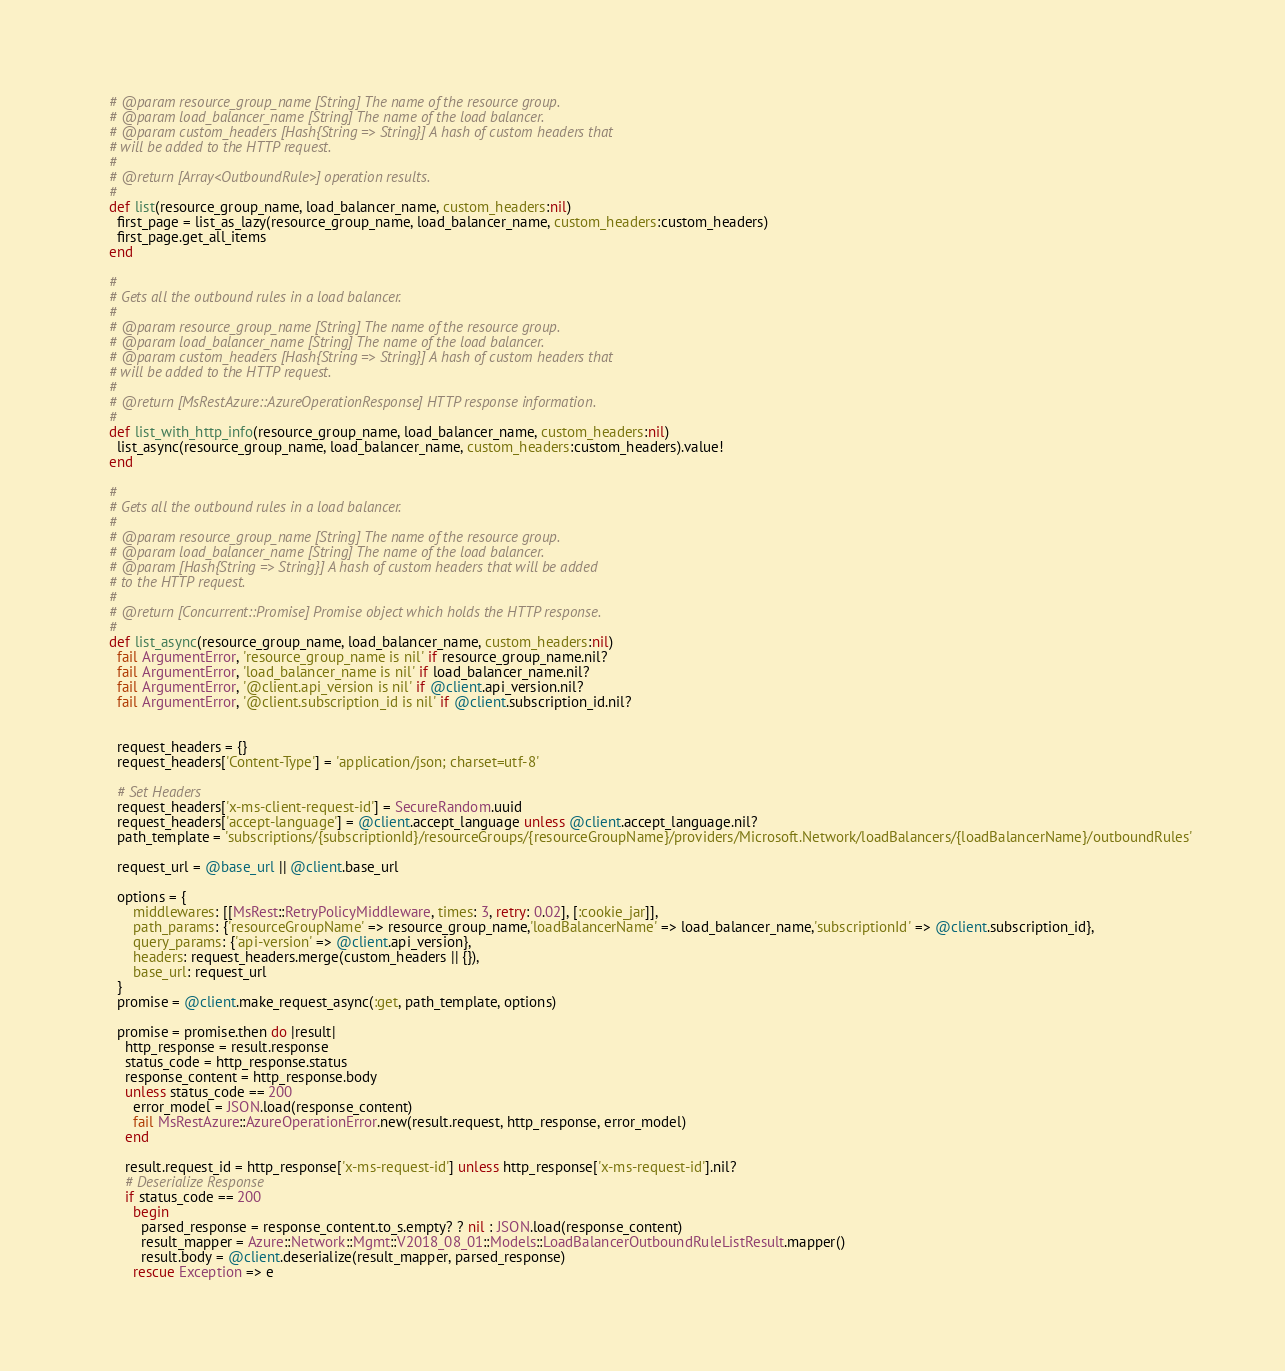Convert code to text. <code><loc_0><loc_0><loc_500><loc_500><_Ruby_>    # @param resource_group_name [String] The name of the resource group.
    # @param load_balancer_name [String] The name of the load balancer.
    # @param custom_headers [Hash{String => String}] A hash of custom headers that
    # will be added to the HTTP request.
    #
    # @return [Array<OutboundRule>] operation results.
    #
    def list(resource_group_name, load_balancer_name, custom_headers:nil)
      first_page = list_as_lazy(resource_group_name, load_balancer_name, custom_headers:custom_headers)
      first_page.get_all_items
    end

    #
    # Gets all the outbound rules in a load balancer.
    #
    # @param resource_group_name [String] The name of the resource group.
    # @param load_balancer_name [String] The name of the load balancer.
    # @param custom_headers [Hash{String => String}] A hash of custom headers that
    # will be added to the HTTP request.
    #
    # @return [MsRestAzure::AzureOperationResponse] HTTP response information.
    #
    def list_with_http_info(resource_group_name, load_balancer_name, custom_headers:nil)
      list_async(resource_group_name, load_balancer_name, custom_headers:custom_headers).value!
    end

    #
    # Gets all the outbound rules in a load balancer.
    #
    # @param resource_group_name [String] The name of the resource group.
    # @param load_balancer_name [String] The name of the load balancer.
    # @param [Hash{String => String}] A hash of custom headers that will be added
    # to the HTTP request.
    #
    # @return [Concurrent::Promise] Promise object which holds the HTTP response.
    #
    def list_async(resource_group_name, load_balancer_name, custom_headers:nil)
      fail ArgumentError, 'resource_group_name is nil' if resource_group_name.nil?
      fail ArgumentError, 'load_balancer_name is nil' if load_balancer_name.nil?
      fail ArgumentError, '@client.api_version is nil' if @client.api_version.nil?
      fail ArgumentError, '@client.subscription_id is nil' if @client.subscription_id.nil?


      request_headers = {}
      request_headers['Content-Type'] = 'application/json; charset=utf-8'

      # Set Headers
      request_headers['x-ms-client-request-id'] = SecureRandom.uuid
      request_headers['accept-language'] = @client.accept_language unless @client.accept_language.nil?
      path_template = 'subscriptions/{subscriptionId}/resourceGroups/{resourceGroupName}/providers/Microsoft.Network/loadBalancers/{loadBalancerName}/outboundRules'

      request_url = @base_url || @client.base_url

      options = {
          middlewares: [[MsRest::RetryPolicyMiddleware, times: 3, retry: 0.02], [:cookie_jar]],
          path_params: {'resourceGroupName' => resource_group_name,'loadBalancerName' => load_balancer_name,'subscriptionId' => @client.subscription_id},
          query_params: {'api-version' => @client.api_version},
          headers: request_headers.merge(custom_headers || {}),
          base_url: request_url
      }
      promise = @client.make_request_async(:get, path_template, options)

      promise = promise.then do |result|
        http_response = result.response
        status_code = http_response.status
        response_content = http_response.body
        unless status_code == 200
          error_model = JSON.load(response_content)
          fail MsRestAzure::AzureOperationError.new(result.request, http_response, error_model)
        end

        result.request_id = http_response['x-ms-request-id'] unless http_response['x-ms-request-id'].nil?
        # Deserialize Response
        if status_code == 200
          begin
            parsed_response = response_content.to_s.empty? ? nil : JSON.load(response_content)
            result_mapper = Azure::Network::Mgmt::V2018_08_01::Models::LoadBalancerOutboundRuleListResult.mapper()
            result.body = @client.deserialize(result_mapper, parsed_response)
          rescue Exception => e</code> 